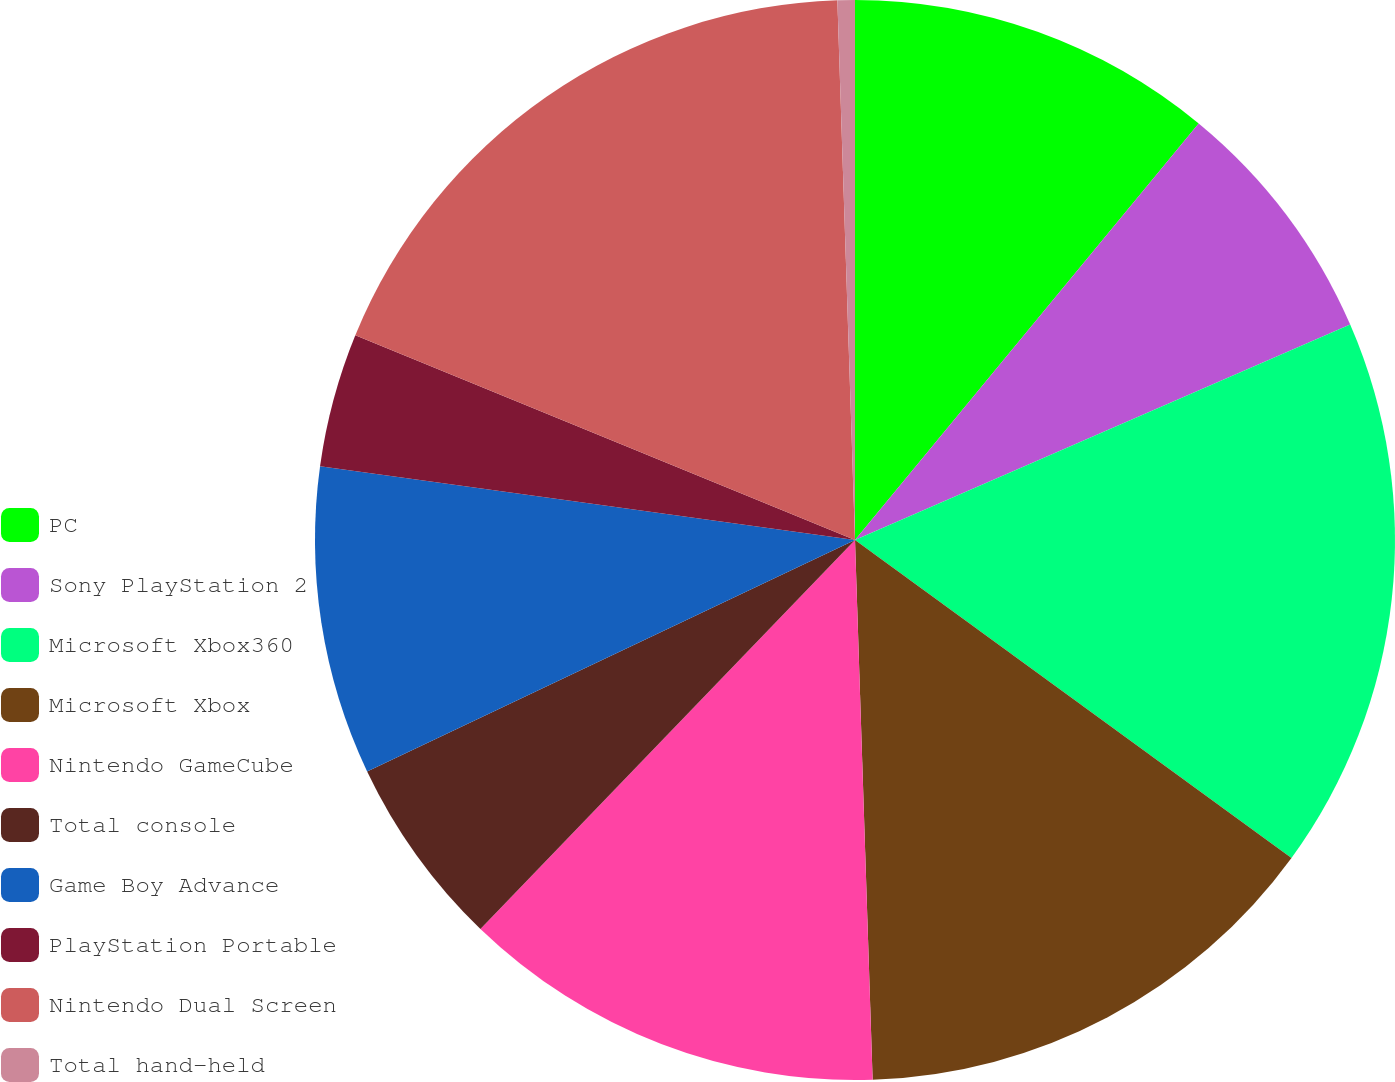Convert chart to OTSL. <chart><loc_0><loc_0><loc_500><loc_500><pie_chart><fcel>PC<fcel>Sony PlayStation 2<fcel>Microsoft Xbox360<fcel>Microsoft Xbox<fcel>Nintendo GameCube<fcel>Total console<fcel>Game Boy Advance<fcel>PlayStation Portable<fcel>Nintendo Dual Screen<fcel>Total hand-held<nl><fcel>10.98%<fcel>7.49%<fcel>16.55%<fcel>14.46%<fcel>12.72%<fcel>5.75%<fcel>9.23%<fcel>4.01%<fcel>18.29%<fcel>0.52%<nl></chart> 